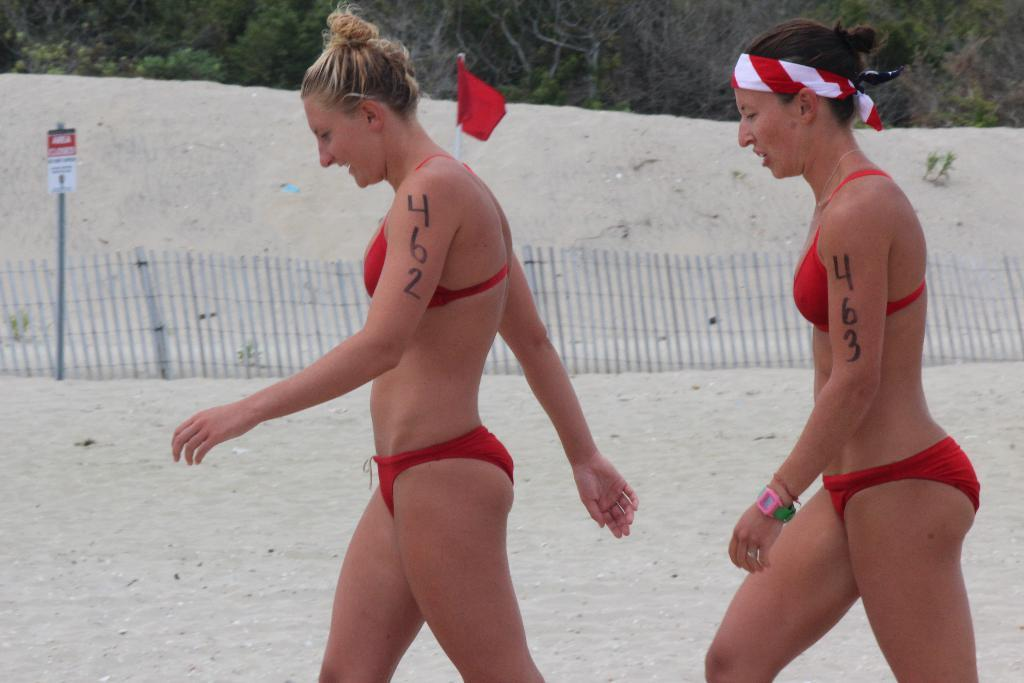How many ladies are in the image? There are two ladies in the image. What can be seen on their hands? There are numbers on their hands. What type of architectural feature is present in the image? There is fencing in the image. What is the symbolic object in the image? There is a flag in the image. What can be used for providing information or directions? There is a signboard in the image. What type of natural elements are present in the image? There are trees and plants in the image. How much dust can be seen on the tray in the image? There is no tray present in the image, so it is not possible to determine the amount of dust on it. 